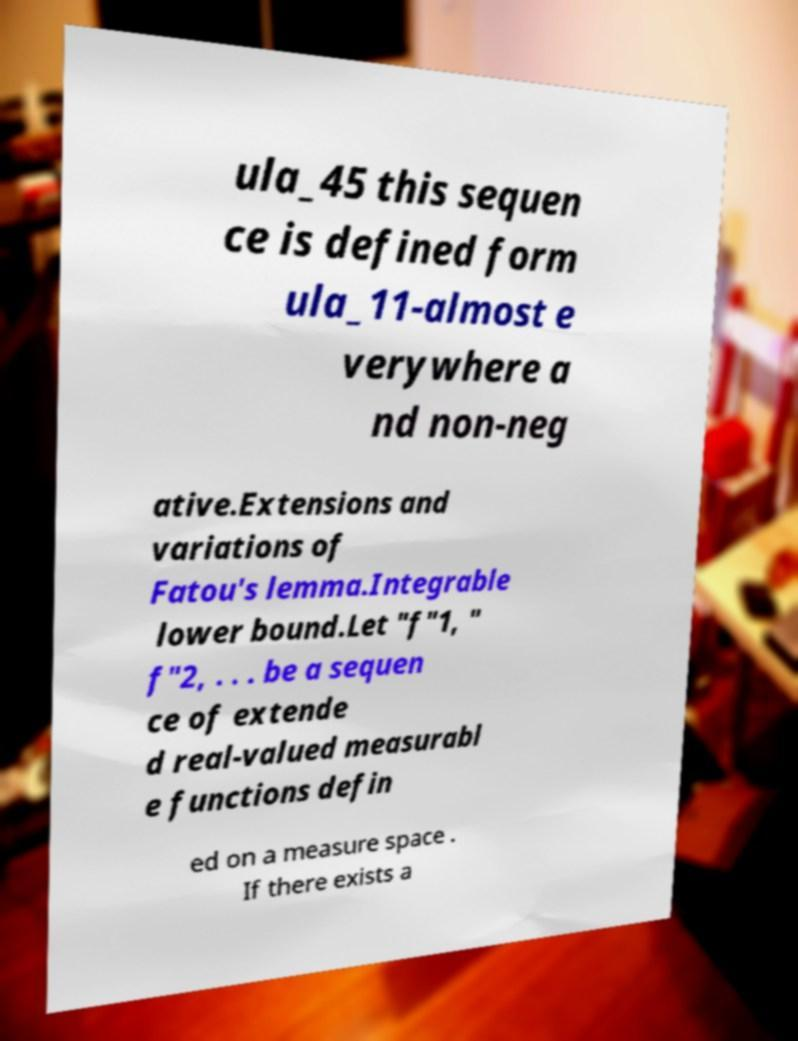Can you read and provide the text displayed in the image?This photo seems to have some interesting text. Can you extract and type it out for me? ula_45 this sequen ce is defined form ula_11-almost e verywhere a nd non-neg ative.Extensions and variations of Fatou's lemma.Integrable lower bound.Let "f"1, " f"2, . . . be a sequen ce of extende d real-valued measurabl e functions defin ed on a measure space . If there exists a 